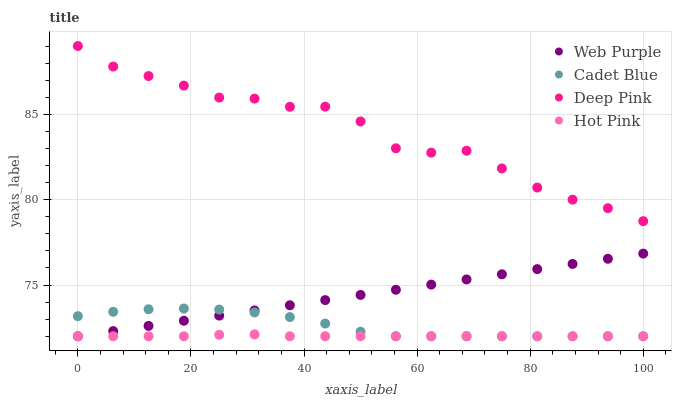Does Hot Pink have the minimum area under the curve?
Answer yes or no. Yes. Does Deep Pink have the maximum area under the curve?
Answer yes or no. Yes. Does Cadet Blue have the minimum area under the curve?
Answer yes or no. No. Does Cadet Blue have the maximum area under the curve?
Answer yes or no. No. Is Web Purple the smoothest?
Answer yes or no. Yes. Is Deep Pink the roughest?
Answer yes or no. Yes. Is Cadet Blue the smoothest?
Answer yes or no. No. Is Cadet Blue the roughest?
Answer yes or no. No. Does Web Purple have the lowest value?
Answer yes or no. Yes. Does Deep Pink have the lowest value?
Answer yes or no. No. Does Deep Pink have the highest value?
Answer yes or no. Yes. Does Cadet Blue have the highest value?
Answer yes or no. No. Is Hot Pink less than Deep Pink?
Answer yes or no. Yes. Is Deep Pink greater than Cadet Blue?
Answer yes or no. Yes. Does Web Purple intersect Cadet Blue?
Answer yes or no. Yes. Is Web Purple less than Cadet Blue?
Answer yes or no. No. Is Web Purple greater than Cadet Blue?
Answer yes or no. No. Does Hot Pink intersect Deep Pink?
Answer yes or no. No. 